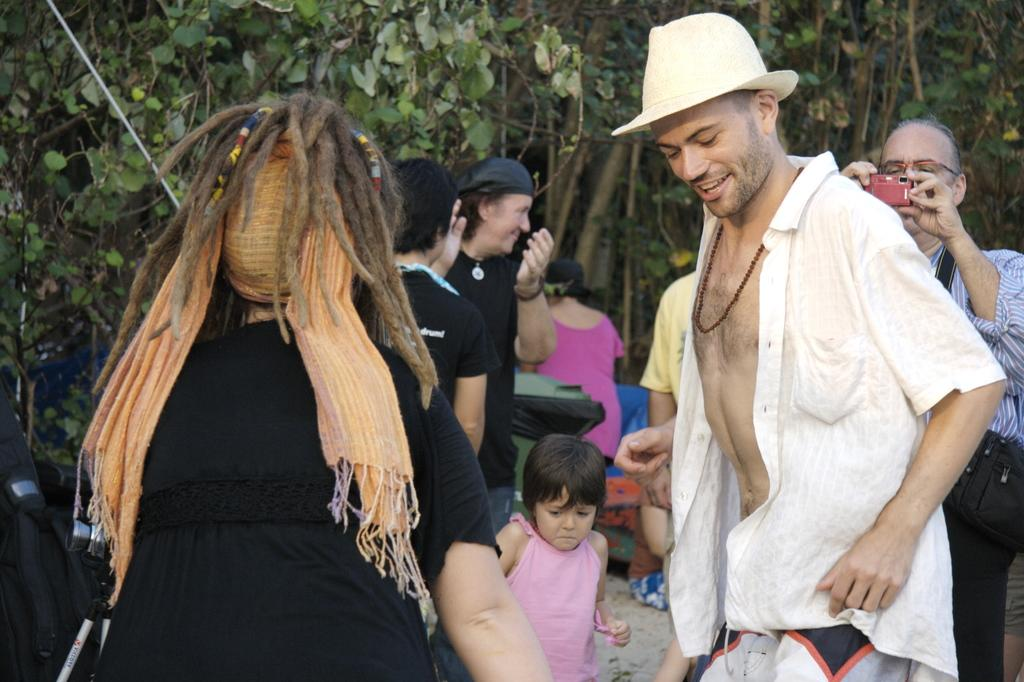How many people can be seen in the image? There are many people in the image. Can you describe the clothing or accessories of any of the people? One person is wearing a hat, and another person is wearing specs. What is the person with specs holding? The person with specs is holding a camera. What can be seen in the background of the image? There are trees in the background of the image. Is there a letter being passed between the people in the image? There is no letter present in the image; it only shows people, a hat, specs, a camera, and trees in the background. 